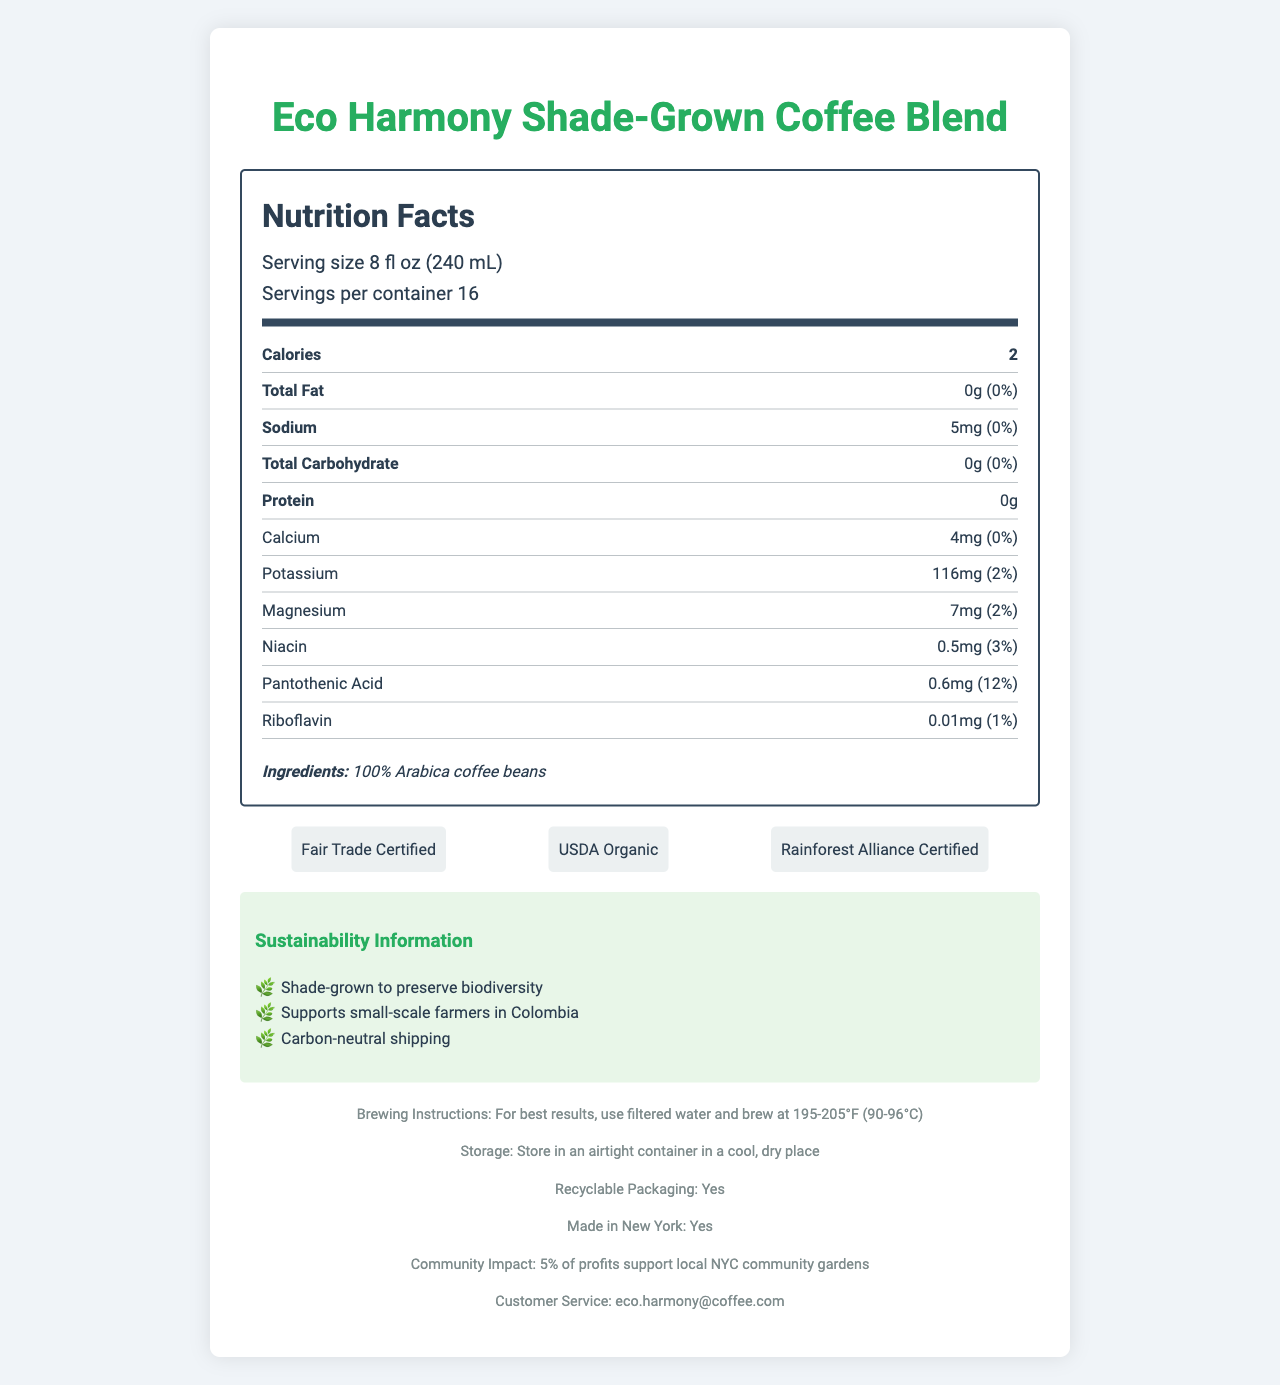what is the serving size? The serving size is clearly listed under the "Serving size" section as 8 fl oz (240 mL).
Answer: 8 fl oz (240 mL) how many servings are there per container? The document lists the number of servings per container as 16.
Answer: 16 how many calories are in one serving? The number of calories per serving is stated as 2 calories.
Answer: 2 what vitamins and minerals are present in the coffee? These vitamins and minerals are detailed in their respective sections with their amounts and daily values.
Answer: Calcium, Potassium, Magnesium, Niacin, Pantothenic Acid, Riboflavin what are the brewing instructions for this coffee? The document provides specific brewing instructions for optimal results.
Answer: For best results, use filtered water and brew at 195-205°F (90-96°C) what is the suggested storage method for the coffee? The storage instructions indicate to store in an airtight container in a cool, dry place.
Answer: Store in an airtight container in a cool, dry place List two certifications the coffee has received. A. Fair Trade Certified B. USDA Organic C. Shade-Grown Certified D. Non-GMO Certified The certifications listed in the document include Fair Trade Certified and USDA Organic, among others.
Answer: A. Fair Trade Certified, B. USDA Organic what is the daily value percentage of pantothenic acid per serving? A. 3% B. 12% C. 2% D. 0% The daily value percentage of pantothenic acid per serving is listed as 12%.
Answer: B. 12% is the packaging of this coffee recyclable? The footer section states that the packaging is recyclable.
Answer: Yes does this coffee support local community initiatives? The document mentions that 5% of profits support local NYC community gardens, indicating community initiative support.
Answer: Yes summarize the main sustainability benefits of this coffee. The document lists these key points under the sustainability information section.
Answer: The coffee is shade-grown to preserve biodiversity, supports small-scale farmers in Colombia, and uses carbon-neutral shipping. what is the postal address for customer service? The document only provides an email address (eco.harmony@coffee.com) for customer service, not a postal address.
Answer: Not enough information 